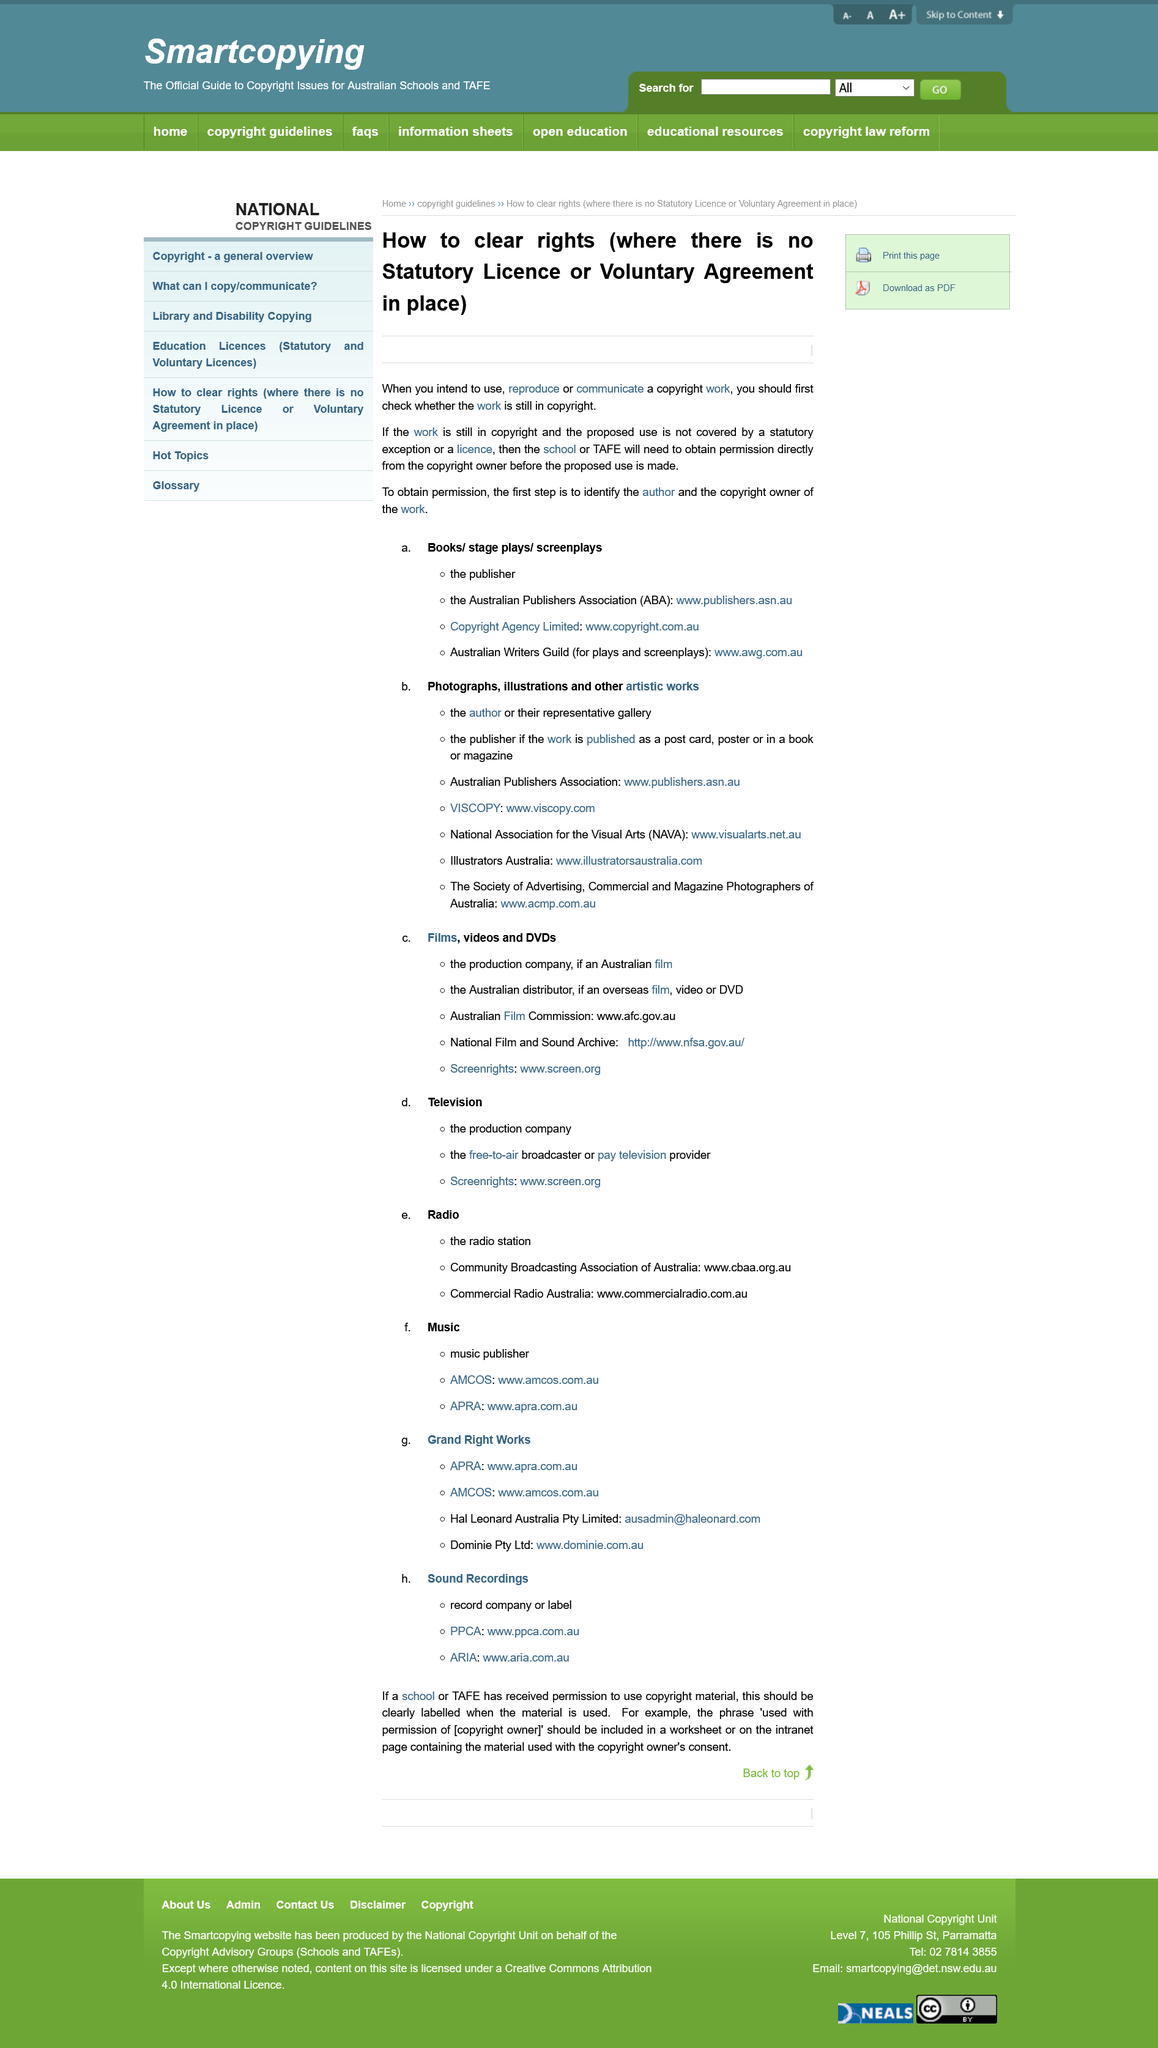Indicate a few pertinent items in this graphic. In situations where the work is still under copyright and the proposed use is not exempted or licensed, the school or TAFE will need to obtain permission directly from the copyright owner before proceeding with the use. The first step to obtain permission to use a copyrighted work is to identify the author and the copyright owner of the work. If you intend to use, reproduce, or communicate a copyright work, it is important to check if the work is still in copyright. 